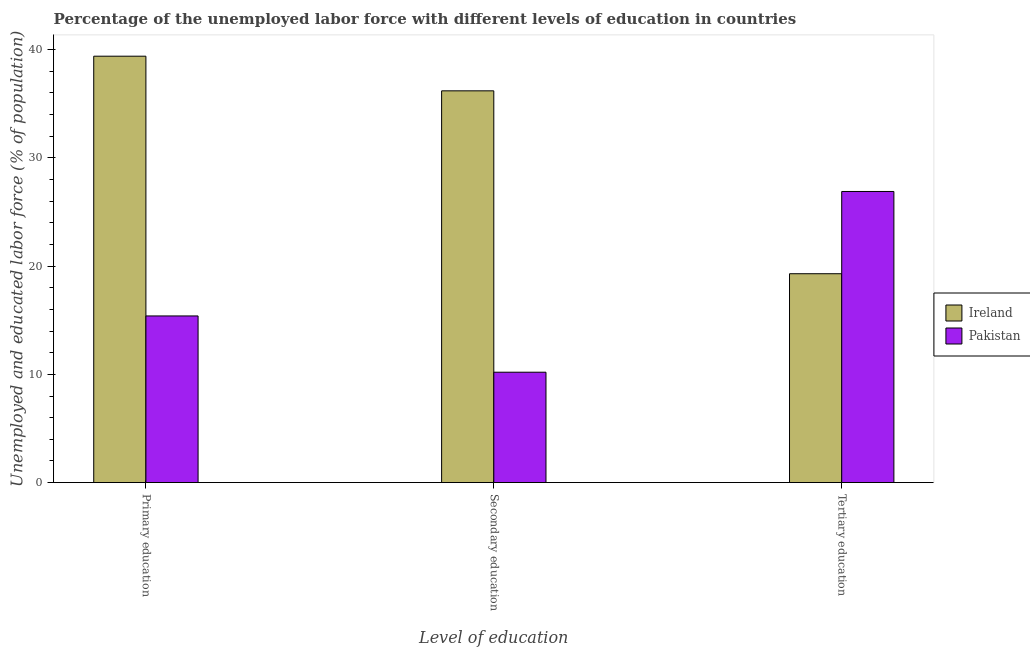How many different coloured bars are there?
Provide a short and direct response. 2. How many groups of bars are there?
Give a very brief answer. 3. Are the number of bars per tick equal to the number of legend labels?
Provide a succinct answer. Yes. How many bars are there on the 1st tick from the left?
Offer a terse response. 2. What is the label of the 2nd group of bars from the left?
Ensure brevity in your answer.  Secondary education. What is the percentage of labor force who received tertiary education in Ireland?
Make the answer very short. 19.3. Across all countries, what is the maximum percentage of labor force who received secondary education?
Give a very brief answer. 36.2. Across all countries, what is the minimum percentage of labor force who received secondary education?
Ensure brevity in your answer.  10.2. In which country was the percentage of labor force who received secondary education maximum?
Keep it short and to the point. Ireland. In which country was the percentage of labor force who received secondary education minimum?
Provide a short and direct response. Pakistan. What is the total percentage of labor force who received tertiary education in the graph?
Keep it short and to the point. 46.2. What is the difference between the percentage of labor force who received secondary education in Pakistan and that in Ireland?
Your answer should be very brief. -26. What is the difference between the percentage of labor force who received secondary education in Pakistan and the percentage of labor force who received tertiary education in Ireland?
Offer a terse response. -9.1. What is the average percentage of labor force who received tertiary education per country?
Make the answer very short. 23.1. What is the difference between the percentage of labor force who received primary education and percentage of labor force who received tertiary education in Pakistan?
Ensure brevity in your answer.  -11.5. In how many countries, is the percentage of labor force who received tertiary education greater than 26 %?
Ensure brevity in your answer.  1. What is the ratio of the percentage of labor force who received primary education in Ireland to that in Pakistan?
Ensure brevity in your answer.  2.56. What is the difference between the highest and the second highest percentage of labor force who received primary education?
Ensure brevity in your answer.  24. What is the difference between the highest and the lowest percentage of labor force who received primary education?
Your answer should be very brief. 24. In how many countries, is the percentage of labor force who received tertiary education greater than the average percentage of labor force who received tertiary education taken over all countries?
Offer a very short reply. 1. What does the 1st bar from the left in Primary education represents?
Make the answer very short. Ireland. What does the 2nd bar from the right in Tertiary education represents?
Your answer should be compact. Ireland. Is it the case that in every country, the sum of the percentage of labor force who received primary education and percentage of labor force who received secondary education is greater than the percentage of labor force who received tertiary education?
Give a very brief answer. No. Are all the bars in the graph horizontal?
Ensure brevity in your answer.  No. How many countries are there in the graph?
Your answer should be compact. 2. Are the values on the major ticks of Y-axis written in scientific E-notation?
Make the answer very short. No. Does the graph contain any zero values?
Your answer should be compact. No. How many legend labels are there?
Your answer should be very brief. 2. What is the title of the graph?
Your answer should be compact. Percentage of the unemployed labor force with different levels of education in countries. What is the label or title of the X-axis?
Offer a very short reply. Level of education. What is the label or title of the Y-axis?
Ensure brevity in your answer.  Unemployed and educated labor force (% of population). What is the Unemployed and educated labor force (% of population) of Ireland in Primary education?
Provide a short and direct response. 39.4. What is the Unemployed and educated labor force (% of population) of Pakistan in Primary education?
Keep it short and to the point. 15.4. What is the Unemployed and educated labor force (% of population) in Ireland in Secondary education?
Make the answer very short. 36.2. What is the Unemployed and educated labor force (% of population) of Pakistan in Secondary education?
Provide a succinct answer. 10.2. What is the Unemployed and educated labor force (% of population) in Ireland in Tertiary education?
Make the answer very short. 19.3. What is the Unemployed and educated labor force (% of population) of Pakistan in Tertiary education?
Make the answer very short. 26.9. Across all Level of education, what is the maximum Unemployed and educated labor force (% of population) of Ireland?
Make the answer very short. 39.4. Across all Level of education, what is the maximum Unemployed and educated labor force (% of population) of Pakistan?
Provide a short and direct response. 26.9. Across all Level of education, what is the minimum Unemployed and educated labor force (% of population) in Ireland?
Offer a terse response. 19.3. Across all Level of education, what is the minimum Unemployed and educated labor force (% of population) of Pakistan?
Your answer should be very brief. 10.2. What is the total Unemployed and educated labor force (% of population) of Ireland in the graph?
Give a very brief answer. 94.9. What is the total Unemployed and educated labor force (% of population) of Pakistan in the graph?
Offer a terse response. 52.5. What is the difference between the Unemployed and educated labor force (% of population) of Pakistan in Primary education and that in Secondary education?
Keep it short and to the point. 5.2. What is the difference between the Unemployed and educated labor force (% of population) in Ireland in Primary education and that in Tertiary education?
Your response must be concise. 20.1. What is the difference between the Unemployed and educated labor force (% of population) of Pakistan in Primary education and that in Tertiary education?
Make the answer very short. -11.5. What is the difference between the Unemployed and educated labor force (% of population) of Ireland in Secondary education and that in Tertiary education?
Your response must be concise. 16.9. What is the difference between the Unemployed and educated labor force (% of population) in Pakistan in Secondary education and that in Tertiary education?
Your response must be concise. -16.7. What is the difference between the Unemployed and educated labor force (% of population) in Ireland in Primary education and the Unemployed and educated labor force (% of population) in Pakistan in Secondary education?
Your answer should be compact. 29.2. What is the difference between the Unemployed and educated labor force (% of population) of Ireland in Primary education and the Unemployed and educated labor force (% of population) of Pakistan in Tertiary education?
Offer a terse response. 12.5. What is the difference between the Unemployed and educated labor force (% of population) of Ireland in Secondary education and the Unemployed and educated labor force (% of population) of Pakistan in Tertiary education?
Your answer should be very brief. 9.3. What is the average Unemployed and educated labor force (% of population) of Ireland per Level of education?
Offer a very short reply. 31.63. What is the difference between the Unemployed and educated labor force (% of population) in Ireland and Unemployed and educated labor force (% of population) in Pakistan in Primary education?
Make the answer very short. 24. What is the difference between the Unemployed and educated labor force (% of population) of Ireland and Unemployed and educated labor force (% of population) of Pakistan in Tertiary education?
Provide a short and direct response. -7.6. What is the ratio of the Unemployed and educated labor force (% of population) of Ireland in Primary education to that in Secondary education?
Your answer should be very brief. 1.09. What is the ratio of the Unemployed and educated labor force (% of population) in Pakistan in Primary education to that in Secondary education?
Make the answer very short. 1.51. What is the ratio of the Unemployed and educated labor force (% of population) of Ireland in Primary education to that in Tertiary education?
Provide a short and direct response. 2.04. What is the ratio of the Unemployed and educated labor force (% of population) in Pakistan in Primary education to that in Tertiary education?
Your answer should be very brief. 0.57. What is the ratio of the Unemployed and educated labor force (% of population) in Ireland in Secondary education to that in Tertiary education?
Provide a succinct answer. 1.88. What is the ratio of the Unemployed and educated labor force (% of population) of Pakistan in Secondary education to that in Tertiary education?
Provide a succinct answer. 0.38. What is the difference between the highest and the lowest Unemployed and educated labor force (% of population) of Ireland?
Give a very brief answer. 20.1. 